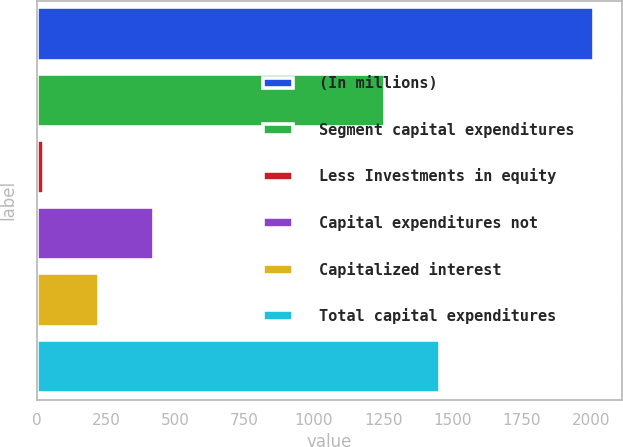Convert chart. <chart><loc_0><loc_0><loc_500><loc_500><bar_chart><fcel>(In millions)<fcel>Segment capital expenditures<fcel>Less Investments in equity<fcel>Capital expenditures not<fcel>Capitalized interest<fcel>Total capital expenditures<nl><fcel>2012<fcel>1256<fcel>28<fcel>424.8<fcel>226.4<fcel>1454.4<nl></chart> 